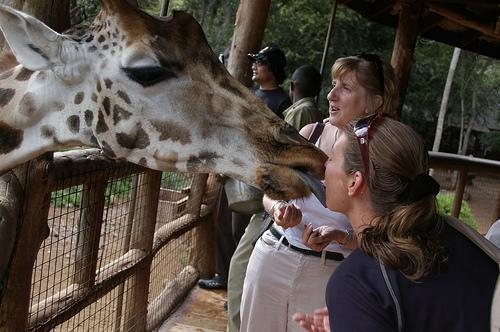How many giraffes are there?
Give a very brief answer. 1. How many people are there?
Give a very brief answer. 4. How many wood polls are in the back?
Give a very brief answer. 2. How many giraffes are there?
Give a very brief answer. 1. How many people can you see?
Give a very brief answer. 3. 